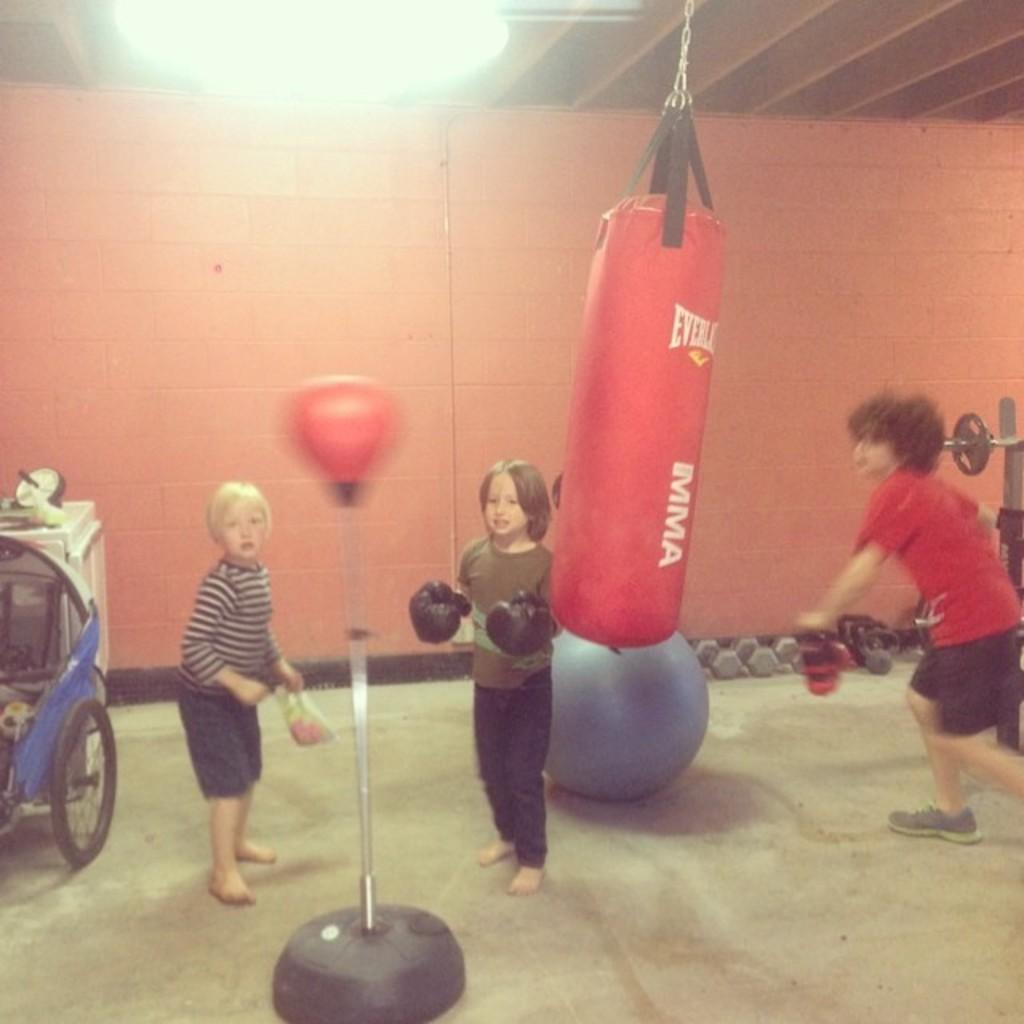Could you give a brief overview of what you see in this image? In this image in the front there is an object which is red and black in colour. In the center there are persons standing and there is a punching bag hanging. On the floor there is a wall on the left side there is an object and on the right side there is an equipment and in the background there is wall. 